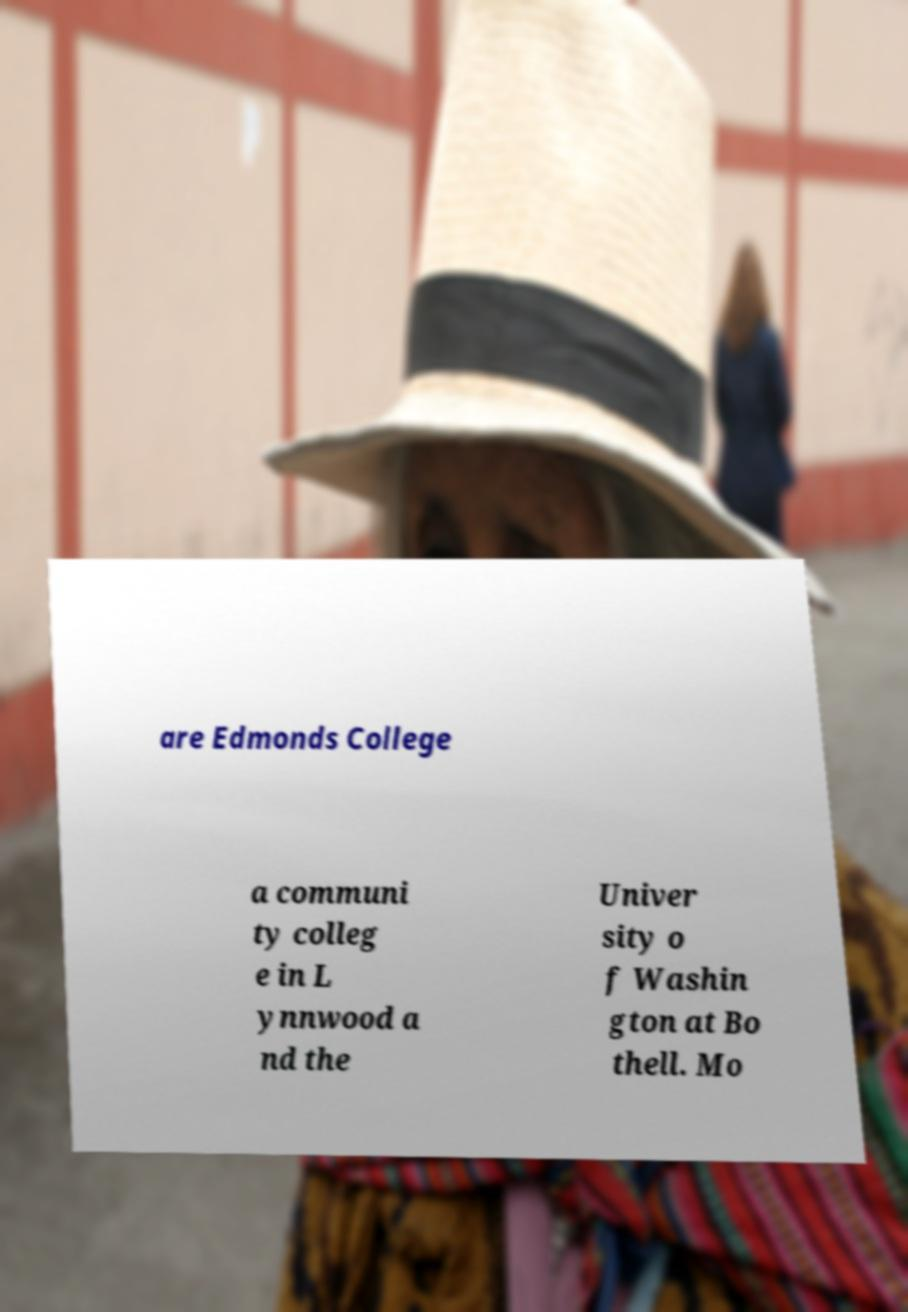Could you extract and type out the text from this image? are Edmonds College a communi ty colleg e in L ynnwood a nd the Univer sity o f Washin gton at Bo thell. Mo 